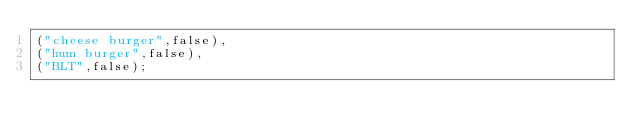Convert code to text. <code><loc_0><loc_0><loc_500><loc_500><_SQL_>("cheese burger",false),
("hum burger",false),
("BLT",false);
</code> 